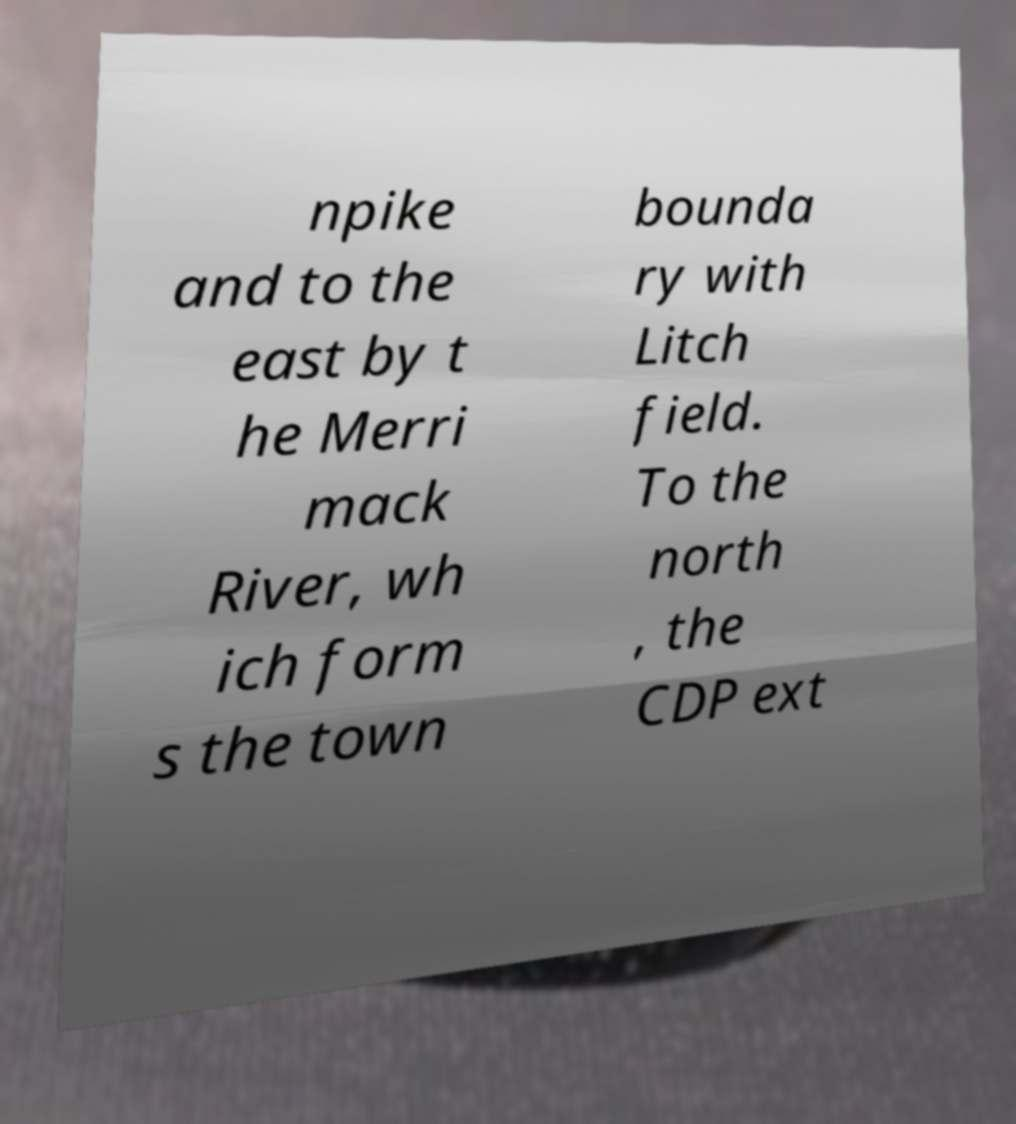I need the written content from this picture converted into text. Can you do that? npike and to the east by t he Merri mack River, wh ich form s the town bounda ry with Litch field. To the north , the CDP ext 